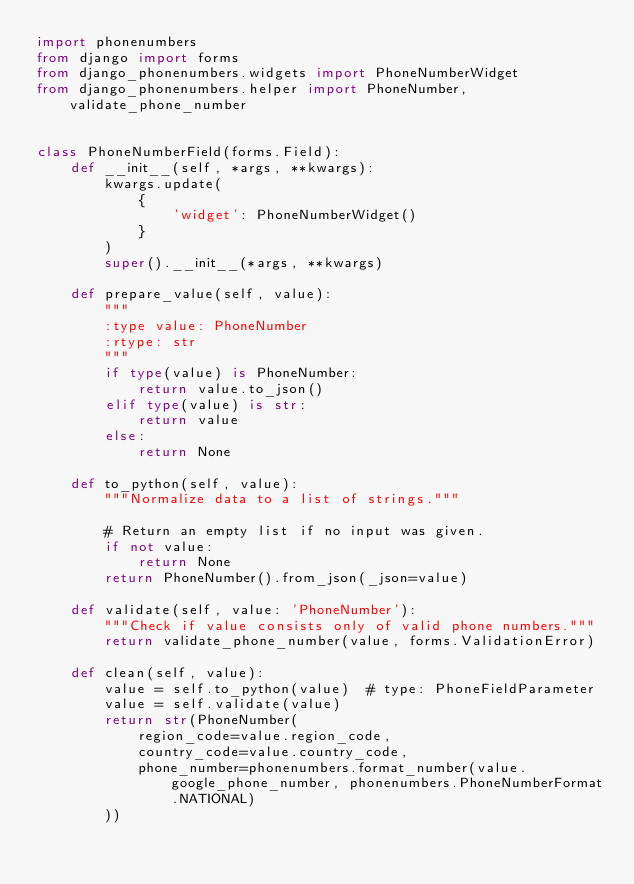Convert code to text. <code><loc_0><loc_0><loc_500><loc_500><_Python_>import phonenumbers
from django import forms
from django_phonenumbers.widgets import PhoneNumberWidget
from django_phonenumbers.helper import PhoneNumber, validate_phone_number


class PhoneNumberField(forms.Field):
    def __init__(self, *args, **kwargs):
        kwargs.update(
            {
                'widget': PhoneNumberWidget()
            }
        )
        super().__init__(*args, **kwargs)

    def prepare_value(self, value):
        """
        :type value: PhoneNumber
        :rtype: str
        """
        if type(value) is PhoneNumber:
            return value.to_json()
        elif type(value) is str:
            return value
        else:
            return None

    def to_python(self, value):
        """Normalize data to a list of strings."""

        # Return an empty list if no input was given.
        if not value:
            return None
        return PhoneNumber().from_json(_json=value)

    def validate(self, value: 'PhoneNumber'):
        """Check if value consists only of valid phone numbers."""
        return validate_phone_number(value, forms.ValidationError)

    def clean(self, value):
        value = self.to_python(value)  # type: PhoneFieldParameter
        value = self.validate(value)
        return str(PhoneNumber(
            region_code=value.region_code,
            country_code=value.country_code,
            phone_number=phonenumbers.format_number(value.google_phone_number, phonenumbers.PhoneNumberFormat.NATIONAL)
        ))
</code> 